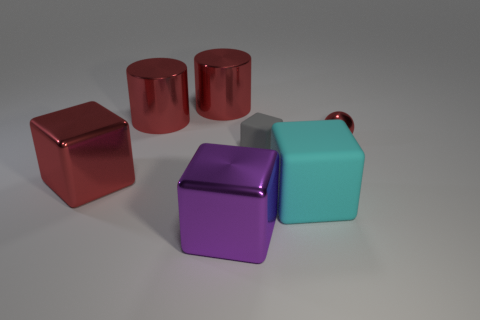Subtract all gray rubber blocks. How many blocks are left? 3 Add 1 cyan rubber objects. How many objects exist? 8 Subtract all balls. How many objects are left? 6 Subtract all purple cubes. How many cubes are left? 3 Subtract 0 gray cylinders. How many objects are left? 7 Subtract 1 balls. How many balls are left? 0 Subtract all blue cylinders. Subtract all purple balls. How many cylinders are left? 2 Subtract all small purple matte spheres. Subtract all red metal cubes. How many objects are left? 6 Add 4 large cyan things. How many large cyan things are left? 5 Add 6 gray blocks. How many gray blocks exist? 7 